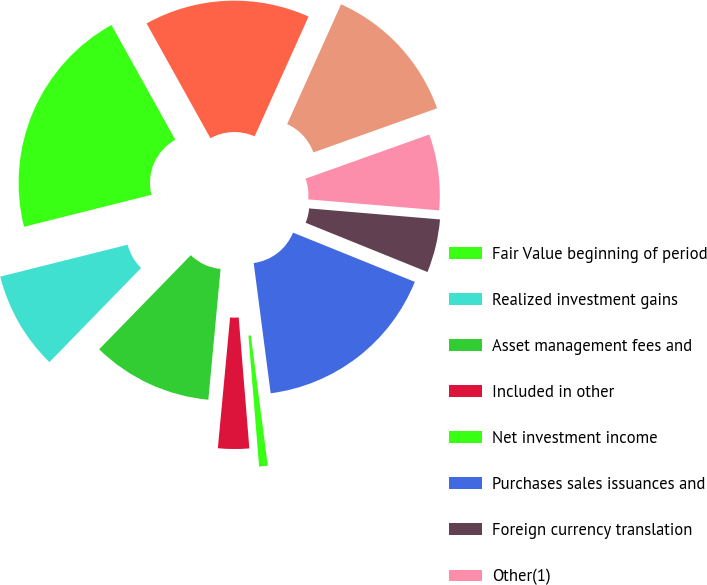<chart> <loc_0><loc_0><loc_500><loc_500><pie_chart><fcel>Fair Value beginning of period<fcel>Realized investment gains<fcel>Asset management fees and<fcel>Included in other<fcel>Net investment income<fcel>Purchases sales issuances and<fcel>Foreign currency translation<fcel>Other(1)<fcel>Transfers into Level 3(2)<fcel>Transfers out of Level 3(2)<nl><fcel>20.83%<fcel>8.8%<fcel>10.8%<fcel>2.78%<fcel>0.77%<fcel>16.82%<fcel>4.78%<fcel>6.79%<fcel>12.81%<fcel>14.81%<nl></chart> 